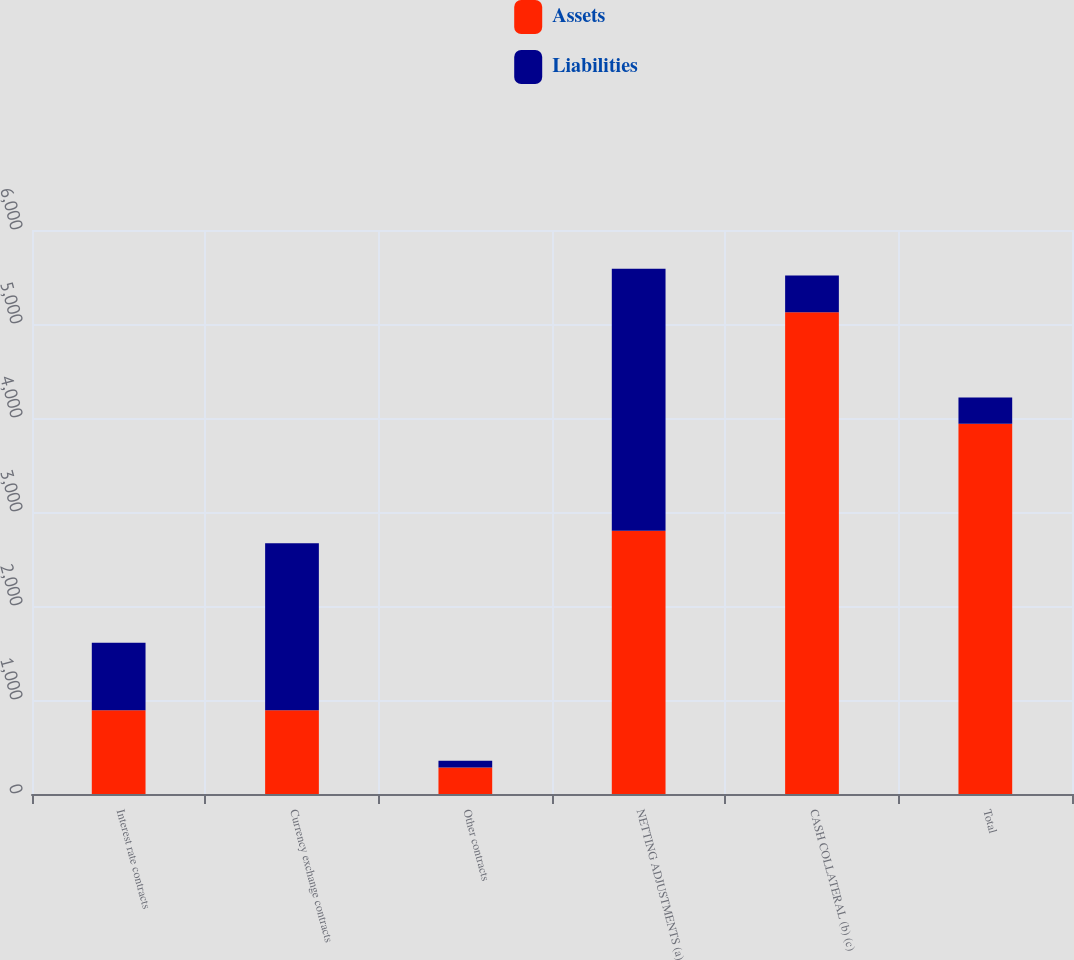Convert chart. <chart><loc_0><loc_0><loc_500><loc_500><stacked_bar_chart><ecel><fcel>Interest rate contracts<fcel>Currency exchange contracts<fcel>Other contracts<fcel>NETTING ADJUSTMENTS (a)<fcel>CASH COLLATERAL (b) (c)<fcel>Total<nl><fcel>Assets<fcel>890<fcel>890<fcel>283<fcel>2801<fcel>5125<fcel>3940<nl><fcel>Liabilities<fcel>719<fcel>1777<fcel>72<fcel>2786<fcel>391<fcel>277<nl></chart> 